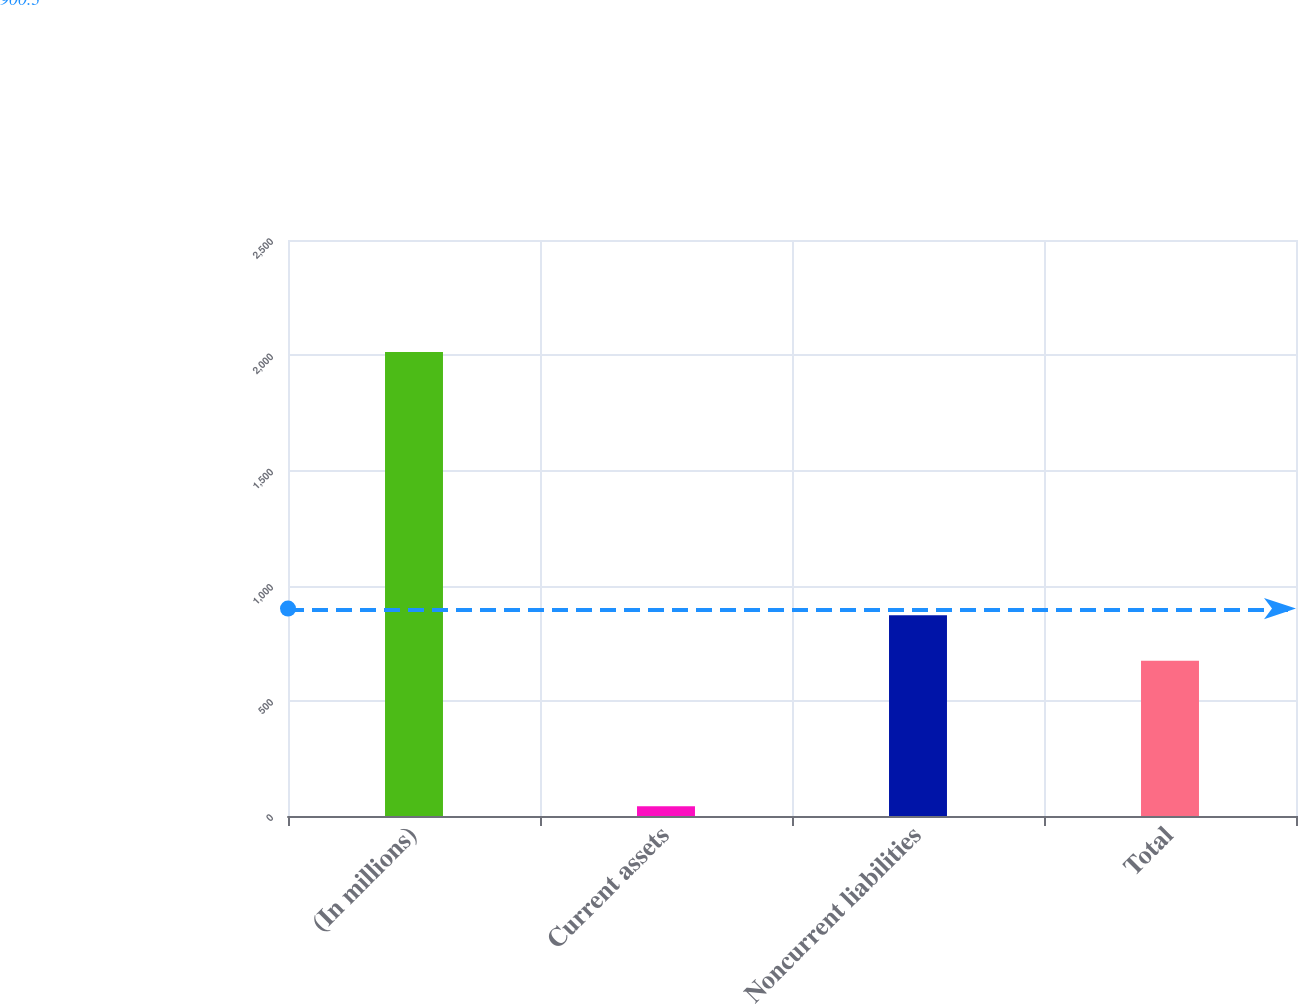<chart> <loc_0><loc_0><loc_500><loc_500><bar_chart><fcel>(In millions)<fcel>Current assets<fcel>Noncurrent liabilities<fcel>Total<nl><fcel>2014<fcel>42<fcel>871.2<fcel>674<nl></chart> 